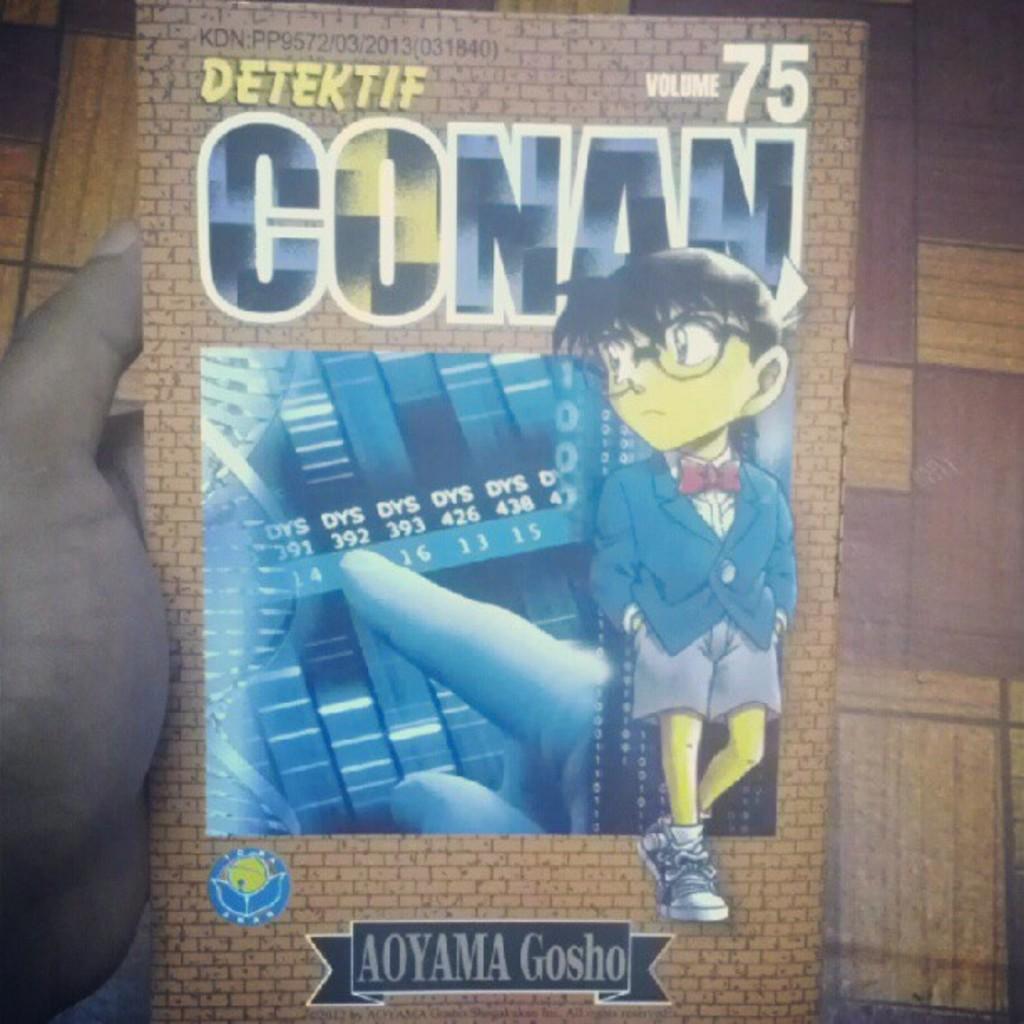Is this a camera?
Your answer should be compact. No. 